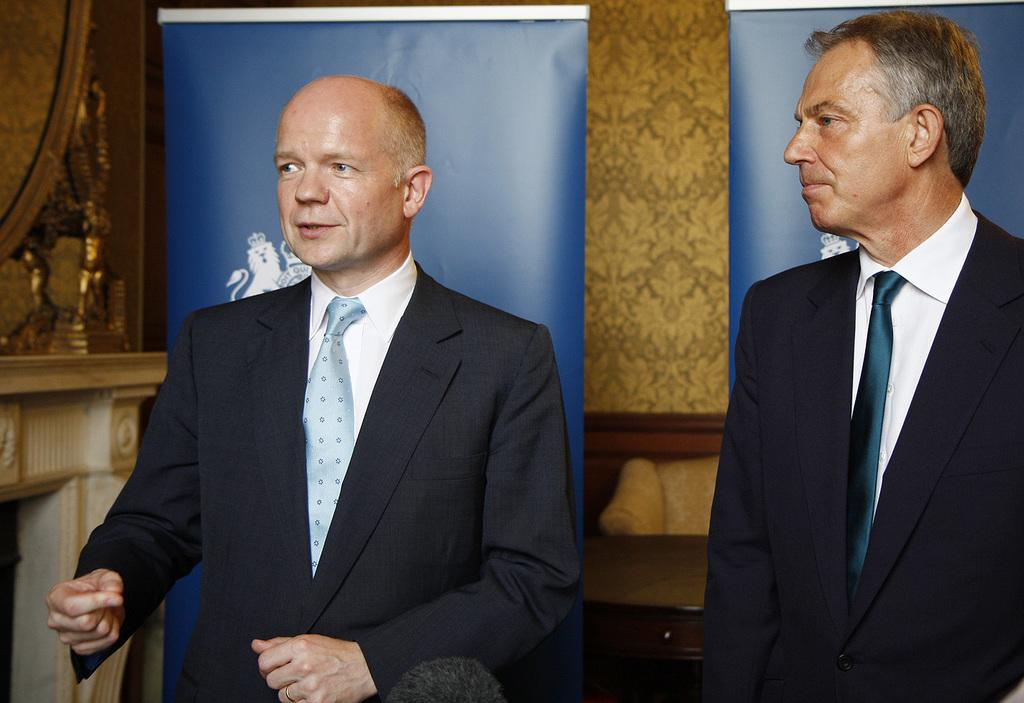How many men are in the image? There are two men in the image. What are the men wearing? The men are wearing suits. What are the men doing in the image? The men are standing. What can be seen in the background of the image? There are banners, a wall, a mirror, and other objects visible in the background of the image. Who is talking in the image? A person is talking in the image. What type of cracker is the man holding in the image? There is no cracker present in the image. What is the man smoking in the image? There is no pipe or any smoking object present in the image. 